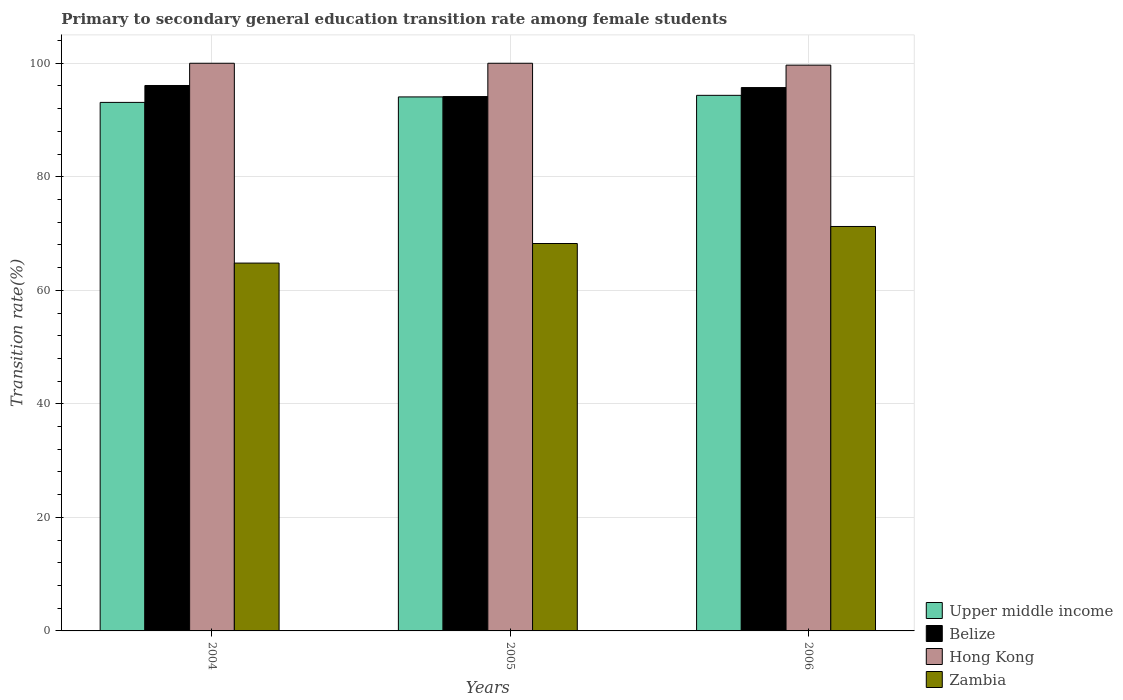How many different coloured bars are there?
Give a very brief answer. 4. Are the number of bars per tick equal to the number of legend labels?
Ensure brevity in your answer.  Yes. Are the number of bars on each tick of the X-axis equal?
Ensure brevity in your answer.  Yes. What is the label of the 1st group of bars from the left?
Ensure brevity in your answer.  2004. In how many cases, is the number of bars for a given year not equal to the number of legend labels?
Your response must be concise. 0. What is the transition rate in Upper middle income in 2006?
Ensure brevity in your answer.  94.35. Across all years, what is the maximum transition rate in Belize?
Ensure brevity in your answer.  96.08. Across all years, what is the minimum transition rate in Zambia?
Your response must be concise. 64.8. In which year was the transition rate in Hong Kong maximum?
Your answer should be compact. 2004. In which year was the transition rate in Hong Kong minimum?
Provide a short and direct response. 2006. What is the total transition rate in Belize in the graph?
Provide a succinct answer. 285.94. What is the difference between the transition rate in Belize in 2005 and that in 2006?
Offer a very short reply. -1.58. What is the difference between the transition rate in Zambia in 2005 and the transition rate in Hong Kong in 2004?
Keep it short and to the point. -31.75. What is the average transition rate in Belize per year?
Give a very brief answer. 95.31. In the year 2005, what is the difference between the transition rate in Belize and transition rate in Zambia?
Keep it short and to the point. 25.89. Is the difference between the transition rate in Belize in 2004 and 2006 greater than the difference between the transition rate in Zambia in 2004 and 2006?
Ensure brevity in your answer.  Yes. What is the difference between the highest and the second highest transition rate in Zambia?
Ensure brevity in your answer.  3. What is the difference between the highest and the lowest transition rate in Upper middle income?
Provide a succinct answer. 1.24. What does the 2nd bar from the left in 2006 represents?
Ensure brevity in your answer.  Belize. What does the 3rd bar from the right in 2006 represents?
Your response must be concise. Belize. Is it the case that in every year, the sum of the transition rate in Belize and transition rate in Hong Kong is greater than the transition rate in Zambia?
Provide a short and direct response. Yes. How many years are there in the graph?
Keep it short and to the point. 3. What is the difference between two consecutive major ticks on the Y-axis?
Keep it short and to the point. 20. Does the graph contain any zero values?
Keep it short and to the point. No. Does the graph contain grids?
Keep it short and to the point. Yes. Where does the legend appear in the graph?
Ensure brevity in your answer.  Bottom right. What is the title of the graph?
Ensure brevity in your answer.  Primary to secondary general education transition rate among female students. Does "Central Europe" appear as one of the legend labels in the graph?
Give a very brief answer. No. What is the label or title of the X-axis?
Provide a short and direct response. Years. What is the label or title of the Y-axis?
Your response must be concise. Transition rate(%). What is the Transition rate(%) in Upper middle income in 2004?
Offer a terse response. 93.11. What is the Transition rate(%) in Belize in 2004?
Your answer should be very brief. 96.08. What is the Transition rate(%) of Zambia in 2004?
Make the answer very short. 64.8. What is the Transition rate(%) in Upper middle income in 2005?
Offer a very short reply. 94.07. What is the Transition rate(%) in Belize in 2005?
Offer a very short reply. 94.13. What is the Transition rate(%) of Zambia in 2005?
Offer a terse response. 68.25. What is the Transition rate(%) in Upper middle income in 2006?
Your response must be concise. 94.35. What is the Transition rate(%) of Belize in 2006?
Your response must be concise. 95.72. What is the Transition rate(%) of Hong Kong in 2006?
Provide a short and direct response. 99.67. What is the Transition rate(%) in Zambia in 2006?
Your answer should be compact. 71.25. Across all years, what is the maximum Transition rate(%) in Upper middle income?
Your response must be concise. 94.35. Across all years, what is the maximum Transition rate(%) in Belize?
Provide a succinct answer. 96.08. Across all years, what is the maximum Transition rate(%) of Hong Kong?
Your answer should be compact. 100. Across all years, what is the maximum Transition rate(%) in Zambia?
Give a very brief answer. 71.25. Across all years, what is the minimum Transition rate(%) in Upper middle income?
Make the answer very short. 93.11. Across all years, what is the minimum Transition rate(%) of Belize?
Provide a succinct answer. 94.13. Across all years, what is the minimum Transition rate(%) of Hong Kong?
Keep it short and to the point. 99.67. Across all years, what is the minimum Transition rate(%) of Zambia?
Your answer should be very brief. 64.8. What is the total Transition rate(%) of Upper middle income in the graph?
Offer a terse response. 281.53. What is the total Transition rate(%) in Belize in the graph?
Make the answer very short. 285.94. What is the total Transition rate(%) of Hong Kong in the graph?
Offer a very short reply. 299.67. What is the total Transition rate(%) of Zambia in the graph?
Your answer should be very brief. 204.29. What is the difference between the Transition rate(%) of Upper middle income in 2004 and that in 2005?
Your answer should be very brief. -0.97. What is the difference between the Transition rate(%) in Belize in 2004 and that in 2005?
Your response must be concise. 1.95. What is the difference between the Transition rate(%) of Hong Kong in 2004 and that in 2005?
Provide a succinct answer. 0. What is the difference between the Transition rate(%) in Zambia in 2004 and that in 2005?
Your answer should be very brief. -3.45. What is the difference between the Transition rate(%) of Upper middle income in 2004 and that in 2006?
Offer a very short reply. -1.24. What is the difference between the Transition rate(%) of Belize in 2004 and that in 2006?
Ensure brevity in your answer.  0.37. What is the difference between the Transition rate(%) in Hong Kong in 2004 and that in 2006?
Keep it short and to the point. 0.33. What is the difference between the Transition rate(%) of Zambia in 2004 and that in 2006?
Offer a terse response. -6.45. What is the difference between the Transition rate(%) in Upper middle income in 2005 and that in 2006?
Provide a succinct answer. -0.28. What is the difference between the Transition rate(%) in Belize in 2005 and that in 2006?
Give a very brief answer. -1.58. What is the difference between the Transition rate(%) in Hong Kong in 2005 and that in 2006?
Your answer should be compact. 0.33. What is the difference between the Transition rate(%) of Zambia in 2005 and that in 2006?
Provide a succinct answer. -3. What is the difference between the Transition rate(%) of Upper middle income in 2004 and the Transition rate(%) of Belize in 2005?
Make the answer very short. -1.03. What is the difference between the Transition rate(%) in Upper middle income in 2004 and the Transition rate(%) in Hong Kong in 2005?
Your answer should be very brief. -6.89. What is the difference between the Transition rate(%) in Upper middle income in 2004 and the Transition rate(%) in Zambia in 2005?
Offer a very short reply. 24.86. What is the difference between the Transition rate(%) in Belize in 2004 and the Transition rate(%) in Hong Kong in 2005?
Ensure brevity in your answer.  -3.92. What is the difference between the Transition rate(%) of Belize in 2004 and the Transition rate(%) of Zambia in 2005?
Offer a terse response. 27.83. What is the difference between the Transition rate(%) in Hong Kong in 2004 and the Transition rate(%) in Zambia in 2005?
Offer a very short reply. 31.75. What is the difference between the Transition rate(%) in Upper middle income in 2004 and the Transition rate(%) in Belize in 2006?
Ensure brevity in your answer.  -2.61. What is the difference between the Transition rate(%) of Upper middle income in 2004 and the Transition rate(%) of Hong Kong in 2006?
Keep it short and to the point. -6.56. What is the difference between the Transition rate(%) in Upper middle income in 2004 and the Transition rate(%) in Zambia in 2006?
Ensure brevity in your answer.  21.86. What is the difference between the Transition rate(%) of Belize in 2004 and the Transition rate(%) of Hong Kong in 2006?
Your response must be concise. -3.58. What is the difference between the Transition rate(%) of Belize in 2004 and the Transition rate(%) of Zambia in 2006?
Offer a very short reply. 24.84. What is the difference between the Transition rate(%) in Hong Kong in 2004 and the Transition rate(%) in Zambia in 2006?
Keep it short and to the point. 28.75. What is the difference between the Transition rate(%) of Upper middle income in 2005 and the Transition rate(%) of Belize in 2006?
Provide a short and direct response. -1.65. What is the difference between the Transition rate(%) of Upper middle income in 2005 and the Transition rate(%) of Hong Kong in 2006?
Provide a short and direct response. -5.6. What is the difference between the Transition rate(%) in Upper middle income in 2005 and the Transition rate(%) in Zambia in 2006?
Offer a terse response. 22.82. What is the difference between the Transition rate(%) in Belize in 2005 and the Transition rate(%) in Hong Kong in 2006?
Provide a succinct answer. -5.53. What is the difference between the Transition rate(%) of Belize in 2005 and the Transition rate(%) of Zambia in 2006?
Offer a terse response. 22.89. What is the difference between the Transition rate(%) of Hong Kong in 2005 and the Transition rate(%) of Zambia in 2006?
Your answer should be very brief. 28.75. What is the average Transition rate(%) of Upper middle income per year?
Keep it short and to the point. 93.84. What is the average Transition rate(%) of Belize per year?
Your answer should be compact. 95.31. What is the average Transition rate(%) in Hong Kong per year?
Keep it short and to the point. 99.89. What is the average Transition rate(%) in Zambia per year?
Your answer should be very brief. 68.1. In the year 2004, what is the difference between the Transition rate(%) of Upper middle income and Transition rate(%) of Belize?
Your answer should be very brief. -2.98. In the year 2004, what is the difference between the Transition rate(%) of Upper middle income and Transition rate(%) of Hong Kong?
Your answer should be compact. -6.89. In the year 2004, what is the difference between the Transition rate(%) of Upper middle income and Transition rate(%) of Zambia?
Provide a short and direct response. 28.31. In the year 2004, what is the difference between the Transition rate(%) in Belize and Transition rate(%) in Hong Kong?
Your answer should be very brief. -3.92. In the year 2004, what is the difference between the Transition rate(%) in Belize and Transition rate(%) in Zambia?
Your response must be concise. 31.28. In the year 2004, what is the difference between the Transition rate(%) in Hong Kong and Transition rate(%) in Zambia?
Offer a terse response. 35.2. In the year 2005, what is the difference between the Transition rate(%) of Upper middle income and Transition rate(%) of Belize?
Ensure brevity in your answer.  -0.06. In the year 2005, what is the difference between the Transition rate(%) in Upper middle income and Transition rate(%) in Hong Kong?
Your answer should be very brief. -5.93. In the year 2005, what is the difference between the Transition rate(%) of Upper middle income and Transition rate(%) of Zambia?
Your answer should be compact. 25.82. In the year 2005, what is the difference between the Transition rate(%) in Belize and Transition rate(%) in Hong Kong?
Offer a terse response. -5.87. In the year 2005, what is the difference between the Transition rate(%) in Belize and Transition rate(%) in Zambia?
Your answer should be very brief. 25.89. In the year 2005, what is the difference between the Transition rate(%) of Hong Kong and Transition rate(%) of Zambia?
Your response must be concise. 31.75. In the year 2006, what is the difference between the Transition rate(%) in Upper middle income and Transition rate(%) in Belize?
Provide a short and direct response. -1.37. In the year 2006, what is the difference between the Transition rate(%) in Upper middle income and Transition rate(%) in Hong Kong?
Your answer should be very brief. -5.32. In the year 2006, what is the difference between the Transition rate(%) in Upper middle income and Transition rate(%) in Zambia?
Your response must be concise. 23.1. In the year 2006, what is the difference between the Transition rate(%) of Belize and Transition rate(%) of Hong Kong?
Provide a short and direct response. -3.95. In the year 2006, what is the difference between the Transition rate(%) of Belize and Transition rate(%) of Zambia?
Your response must be concise. 24.47. In the year 2006, what is the difference between the Transition rate(%) in Hong Kong and Transition rate(%) in Zambia?
Your response must be concise. 28.42. What is the ratio of the Transition rate(%) in Upper middle income in 2004 to that in 2005?
Give a very brief answer. 0.99. What is the ratio of the Transition rate(%) of Belize in 2004 to that in 2005?
Your answer should be very brief. 1.02. What is the ratio of the Transition rate(%) of Hong Kong in 2004 to that in 2005?
Keep it short and to the point. 1. What is the ratio of the Transition rate(%) in Zambia in 2004 to that in 2005?
Offer a terse response. 0.95. What is the ratio of the Transition rate(%) in Upper middle income in 2004 to that in 2006?
Make the answer very short. 0.99. What is the ratio of the Transition rate(%) in Zambia in 2004 to that in 2006?
Keep it short and to the point. 0.91. What is the ratio of the Transition rate(%) in Upper middle income in 2005 to that in 2006?
Ensure brevity in your answer.  1. What is the ratio of the Transition rate(%) of Belize in 2005 to that in 2006?
Ensure brevity in your answer.  0.98. What is the ratio of the Transition rate(%) in Zambia in 2005 to that in 2006?
Offer a terse response. 0.96. What is the difference between the highest and the second highest Transition rate(%) of Upper middle income?
Make the answer very short. 0.28. What is the difference between the highest and the second highest Transition rate(%) of Belize?
Give a very brief answer. 0.37. What is the difference between the highest and the second highest Transition rate(%) of Zambia?
Ensure brevity in your answer.  3. What is the difference between the highest and the lowest Transition rate(%) in Upper middle income?
Your answer should be compact. 1.24. What is the difference between the highest and the lowest Transition rate(%) of Belize?
Keep it short and to the point. 1.95. What is the difference between the highest and the lowest Transition rate(%) of Hong Kong?
Your response must be concise. 0.33. What is the difference between the highest and the lowest Transition rate(%) of Zambia?
Your response must be concise. 6.45. 